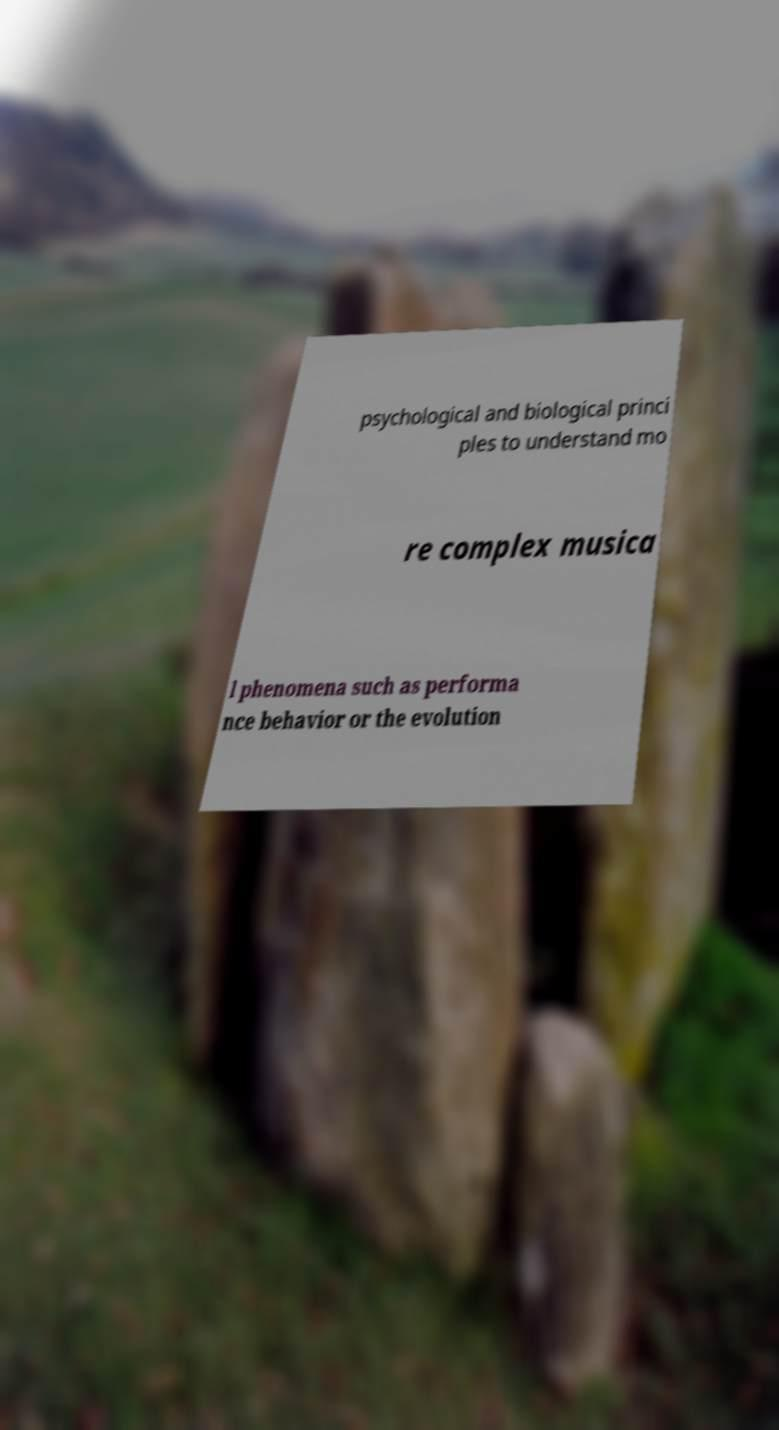I need the written content from this picture converted into text. Can you do that? psychological and biological princi ples to understand mo re complex musica l phenomena such as performa nce behavior or the evolution 